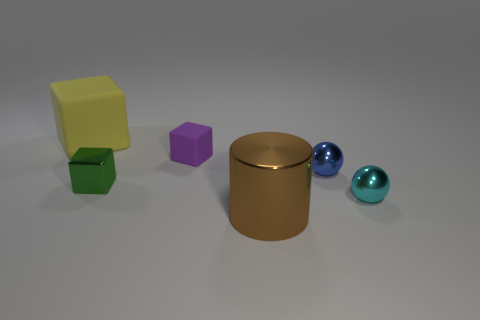There is a yellow object that is the same shape as the small green shiny object; what is it made of?
Give a very brief answer. Rubber. Does the rubber object that is on the left side of the green shiny thing have the same size as the matte cube that is in front of the yellow matte object?
Your answer should be very brief. No. The large thing that is in front of the big object to the left of the metallic cylinder is made of what material?
Provide a short and direct response. Metal. Are there fewer metallic balls that are behind the tiny purple rubber block than blue shiny objects?
Offer a very short reply. Yes. There is a small cyan object that is made of the same material as the green object; what shape is it?
Keep it short and to the point. Sphere. How many other objects are the same shape as the large rubber thing?
Your response must be concise. 2. What number of yellow objects are either large cylinders or tiny cubes?
Your answer should be compact. 0. Is the purple thing the same shape as the tiny green metallic object?
Your answer should be very brief. Yes. Is there a cyan metal sphere that is behind the large object in front of the yellow thing?
Offer a very short reply. Yes. Is the number of small cyan shiny spheres that are in front of the cyan ball the same as the number of purple shiny objects?
Provide a short and direct response. Yes. 